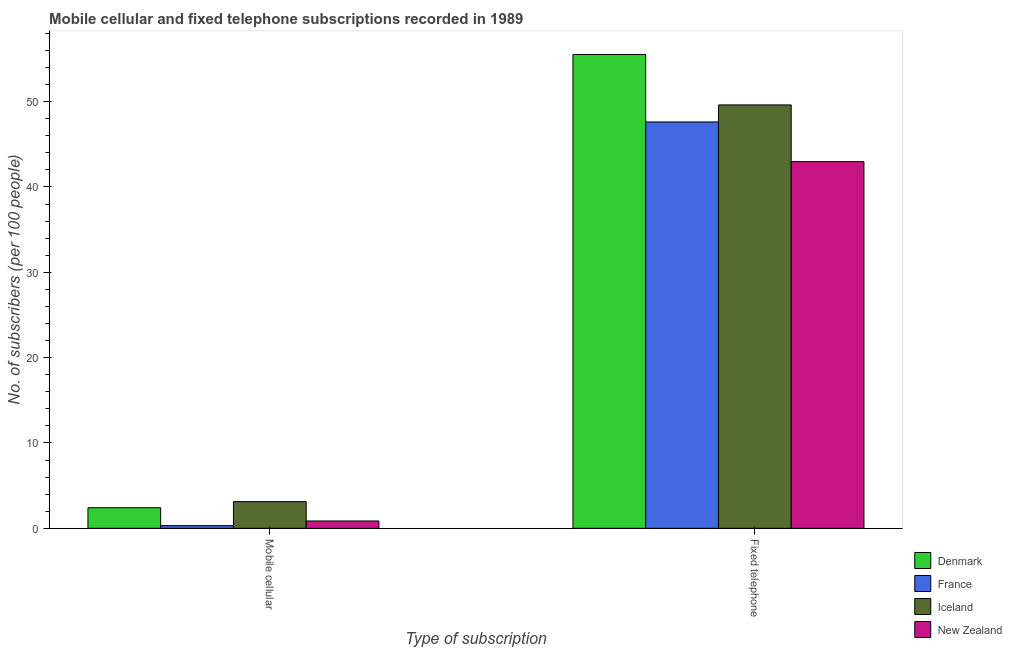How many different coloured bars are there?
Offer a terse response. 4. How many groups of bars are there?
Make the answer very short. 2. Are the number of bars per tick equal to the number of legend labels?
Keep it short and to the point. Yes. How many bars are there on the 1st tick from the right?
Offer a very short reply. 4. What is the label of the 2nd group of bars from the left?
Your answer should be compact. Fixed telephone. What is the number of mobile cellular subscribers in Denmark?
Give a very brief answer. 2.41. Across all countries, what is the maximum number of mobile cellular subscribers?
Ensure brevity in your answer.  3.13. Across all countries, what is the minimum number of fixed telephone subscribers?
Provide a succinct answer. 42.97. In which country was the number of fixed telephone subscribers maximum?
Your response must be concise. Denmark. In which country was the number of mobile cellular subscribers minimum?
Your answer should be compact. France. What is the total number of mobile cellular subscribers in the graph?
Your answer should be compact. 6.72. What is the difference between the number of fixed telephone subscribers in France and that in Denmark?
Give a very brief answer. -7.9. What is the difference between the number of mobile cellular subscribers in Iceland and the number of fixed telephone subscribers in Denmark?
Provide a succinct answer. -52.39. What is the average number of fixed telephone subscribers per country?
Your answer should be compact. 48.93. What is the difference between the number of fixed telephone subscribers and number of mobile cellular subscribers in Denmark?
Make the answer very short. 53.11. In how many countries, is the number of mobile cellular subscribers greater than 56 ?
Your answer should be compact. 0. What is the ratio of the number of fixed telephone subscribers in Iceland to that in New Zealand?
Your response must be concise. 1.15. Is the number of mobile cellular subscribers in Denmark less than that in France?
Keep it short and to the point. No. What does the 1st bar from the left in Fixed telephone represents?
Give a very brief answer. Denmark. How many bars are there?
Ensure brevity in your answer.  8. How many countries are there in the graph?
Your answer should be very brief. 4. Does the graph contain any zero values?
Ensure brevity in your answer.  No. Does the graph contain grids?
Your response must be concise. No. Where does the legend appear in the graph?
Provide a short and direct response. Bottom right. How many legend labels are there?
Offer a very short reply. 4. What is the title of the graph?
Your response must be concise. Mobile cellular and fixed telephone subscriptions recorded in 1989. Does "Rwanda" appear as one of the legend labels in the graph?
Provide a short and direct response. No. What is the label or title of the X-axis?
Your answer should be compact. Type of subscription. What is the label or title of the Y-axis?
Your answer should be very brief. No. of subscribers (per 100 people). What is the No. of subscribers (per 100 people) in Denmark in Mobile cellular?
Offer a very short reply. 2.41. What is the No. of subscribers (per 100 people) of France in Mobile cellular?
Provide a succinct answer. 0.32. What is the No. of subscribers (per 100 people) in Iceland in Mobile cellular?
Your answer should be very brief. 3.13. What is the No. of subscribers (per 100 people) in New Zealand in Mobile cellular?
Make the answer very short. 0.86. What is the No. of subscribers (per 100 people) in Denmark in Fixed telephone?
Keep it short and to the point. 55.52. What is the No. of subscribers (per 100 people) of France in Fixed telephone?
Keep it short and to the point. 47.62. What is the No. of subscribers (per 100 people) of Iceland in Fixed telephone?
Offer a terse response. 49.61. What is the No. of subscribers (per 100 people) of New Zealand in Fixed telephone?
Ensure brevity in your answer.  42.97. Across all Type of subscription, what is the maximum No. of subscribers (per 100 people) in Denmark?
Your response must be concise. 55.52. Across all Type of subscription, what is the maximum No. of subscribers (per 100 people) of France?
Your answer should be very brief. 47.62. Across all Type of subscription, what is the maximum No. of subscribers (per 100 people) in Iceland?
Provide a short and direct response. 49.61. Across all Type of subscription, what is the maximum No. of subscribers (per 100 people) in New Zealand?
Your answer should be compact. 42.97. Across all Type of subscription, what is the minimum No. of subscribers (per 100 people) in Denmark?
Your answer should be compact. 2.41. Across all Type of subscription, what is the minimum No. of subscribers (per 100 people) in France?
Your answer should be compact. 0.32. Across all Type of subscription, what is the minimum No. of subscribers (per 100 people) in Iceland?
Keep it short and to the point. 3.13. Across all Type of subscription, what is the minimum No. of subscribers (per 100 people) in New Zealand?
Provide a succinct answer. 0.86. What is the total No. of subscribers (per 100 people) in Denmark in the graph?
Offer a very short reply. 57.93. What is the total No. of subscribers (per 100 people) in France in the graph?
Offer a very short reply. 47.93. What is the total No. of subscribers (per 100 people) of Iceland in the graph?
Make the answer very short. 52.74. What is the total No. of subscribers (per 100 people) in New Zealand in the graph?
Your answer should be compact. 43.83. What is the difference between the No. of subscribers (per 100 people) of Denmark in Mobile cellular and that in Fixed telephone?
Give a very brief answer. -53.11. What is the difference between the No. of subscribers (per 100 people) in France in Mobile cellular and that in Fixed telephone?
Offer a terse response. -47.3. What is the difference between the No. of subscribers (per 100 people) of Iceland in Mobile cellular and that in Fixed telephone?
Offer a terse response. -46.48. What is the difference between the No. of subscribers (per 100 people) in New Zealand in Mobile cellular and that in Fixed telephone?
Your answer should be compact. -42.11. What is the difference between the No. of subscribers (per 100 people) in Denmark in Mobile cellular and the No. of subscribers (per 100 people) in France in Fixed telephone?
Ensure brevity in your answer.  -45.2. What is the difference between the No. of subscribers (per 100 people) of Denmark in Mobile cellular and the No. of subscribers (per 100 people) of Iceland in Fixed telephone?
Make the answer very short. -47.2. What is the difference between the No. of subscribers (per 100 people) in Denmark in Mobile cellular and the No. of subscribers (per 100 people) in New Zealand in Fixed telephone?
Offer a terse response. -40.55. What is the difference between the No. of subscribers (per 100 people) of France in Mobile cellular and the No. of subscribers (per 100 people) of Iceland in Fixed telephone?
Make the answer very short. -49.3. What is the difference between the No. of subscribers (per 100 people) of France in Mobile cellular and the No. of subscribers (per 100 people) of New Zealand in Fixed telephone?
Keep it short and to the point. -42.65. What is the difference between the No. of subscribers (per 100 people) in Iceland in Mobile cellular and the No. of subscribers (per 100 people) in New Zealand in Fixed telephone?
Your answer should be compact. -39.84. What is the average No. of subscribers (per 100 people) of Denmark per Type of subscription?
Your answer should be compact. 28.97. What is the average No. of subscribers (per 100 people) in France per Type of subscription?
Your response must be concise. 23.97. What is the average No. of subscribers (per 100 people) in Iceland per Type of subscription?
Ensure brevity in your answer.  26.37. What is the average No. of subscribers (per 100 people) of New Zealand per Type of subscription?
Provide a short and direct response. 21.91. What is the difference between the No. of subscribers (per 100 people) in Denmark and No. of subscribers (per 100 people) in France in Mobile cellular?
Make the answer very short. 2.1. What is the difference between the No. of subscribers (per 100 people) of Denmark and No. of subscribers (per 100 people) of Iceland in Mobile cellular?
Your response must be concise. -0.72. What is the difference between the No. of subscribers (per 100 people) of Denmark and No. of subscribers (per 100 people) of New Zealand in Mobile cellular?
Your response must be concise. 1.55. What is the difference between the No. of subscribers (per 100 people) of France and No. of subscribers (per 100 people) of Iceland in Mobile cellular?
Keep it short and to the point. -2.81. What is the difference between the No. of subscribers (per 100 people) of France and No. of subscribers (per 100 people) of New Zealand in Mobile cellular?
Offer a very short reply. -0.54. What is the difference between the No. of subscribers (per 100 people) of Iceland and No. of subscribers (per 100 people) of New Zealand in Mobile cellular?
Keep it short and to the point. 2.27. What is the difference between the No. of subscribers (per 100 people) in Denmark and No. of subscribers (per 100 people) in France in Fixed telephone?
Keep it short and to the point. 7.9. What is the difference between the No. of subscribers (per 100 people) in Denmark and No. of subscribers (per 100 people) in Iceland in Fixed telephone?
Give a very brief answer. 5.91. What is the difference between the No. of subscribers (per 100 people) in Denmark and No. of subscribers (per 100 people) in New Zealand in Fixed telephone?
Offer a very short reply. 12.55. What is the difference between the No. of subscribers (per 100 people) of France and No. of subscribers (per 100 people) of Iceland in Fixed telephone?
Ensure brevity in your answer.  -2. What is the difference between the No. of subscribers (per 100 people) of France and No. of subscribers (per 100 people) of New Zealand in Fixed telephone?
Offer a very short reply. 4.65. What is the difference between the No. of subscribers (per 100 people) in Iceland and No. of subscribers (per 100 people) in New Zealand in Fixed telephone?
Make the answer very short. 6.65. What is the ratio of the No. of subscribers (per 100 people) of Denmark in Mobile cellular to that in Fixed telephone?
Your answer should be compact. 0.04. What is the ratio of the No. of subscribers (per 100 people) of France in Mobile cellular to that in Fixed telephone?
Provide a short and direct response. 0.01. What is the ratio of the No. of subscribers (per 100 people) in Iceland in Mobile cellular to that in Fixed telephone?
Keep it short and to the point. 0.06. What is the ratio of the No. of subscribers (per 100 people) of New Zealand in Mobile cellular to that in Fixed telephone?
Your response must be concise. 0.02. What is the difference between the highest and the second highest No. of subscribers (per 100 people) in Denmark?
Make the answer very short. 53.11. What is the difference between the highest and the second highest No. of subscribers (per 100 people) in France?
Make the answer very short. 47.3. What is the difference between the highest and the second highest No. of subscribers (per 100 people) in Iceland?
Your answer should be compact. 46.48. What is the difference between the highest and the second highest No. of subscribers (per 100 people) in New Zealand?
Ensure brevity in your answer.  42.11. What is the difference between the highest and the lowest No. of subscribers (per 100 people) in Denmark?
Give a very brief answer. 53.11. What is the difference between the highest and the lowest No. of subscribers (per 100 people) of France?
Ensure brevity in your answer.  47.3. What is the difference between the highest and the lowest No. of subscribers (per 100 people) in Iceland?
Offer a very short reply. 46.48. What is the difference between the highest and the lowest No. of subscribers (per 100 people) in New Zealand?
Your answer should be very brief. 42.11. 